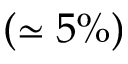Convert formula to latex. <formula><loc_0><loc_0><loc_500><loc_500>( \simeq 5 \% )</formula> 